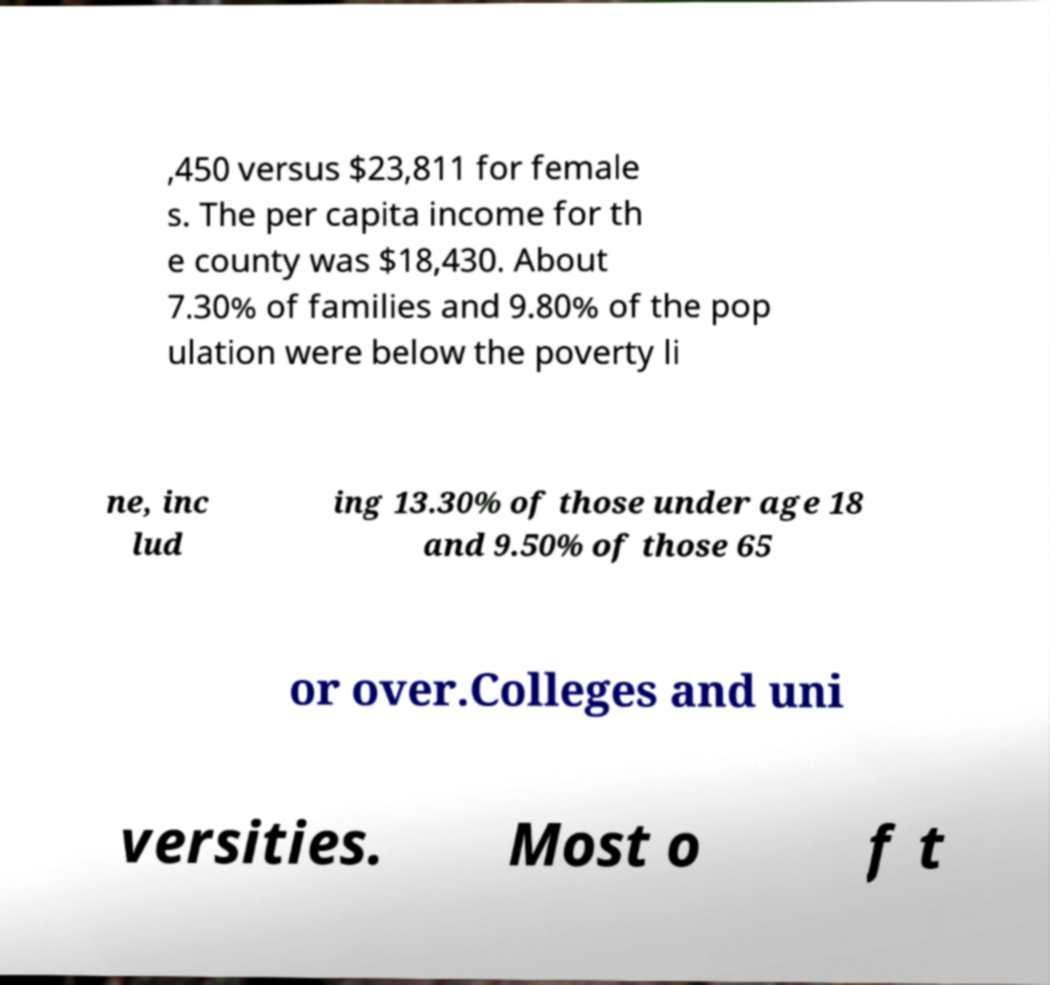Can you accurately transcribe the text from the provided image for me? ,450 versus $23,811 for female s. The per capita income for th e county was $18,430. About 7.30% of families and 9.80% of the pop ulation were below the poverty li ne, inc lud ing 13.30% of those under age 18 and 9.50% of those 65 or over.Colleges and uni versities. Most o f t 